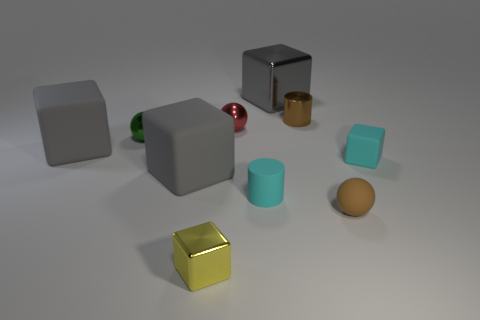Is there anything else that is the same material as the red object?
Give a very brief answer. Yes. Does the tiny metallic object that is on the left side of the small metallic block have the same shape as the big metal thing?
Make the answer very short. No. What number of tiny rubber objects are both behind the brown ball and to the right of the tiny shiny cylinder?
Your response must be concise. 1. The small rubber thing in front of the rubber cylinder has what shape?
Keep it short and to the point. Sphere. What number of small yellow cubes have the same material as the small green ball?
Your answer should be very brief. 1. Does the brown metallic thing have the same shape as the tiny yellow thing that is left of the metal cylinder?
Your answer should be very brief. No. Are there any green metal things that are to the right of the cyan object that is left of the gray thing behind the tiny green sphere?
Your response must be concise. No. What size is the shiny block behind the tiny red shiny ball?
Offer a very short reply. Large. There is a yellow cube that is the same size as the brown ball; what material is it?
Ensure brevity in your answer.  Metal. Is the small red object the same shape as the brown rubber thing?
Provide a short and direct response. Yes. 